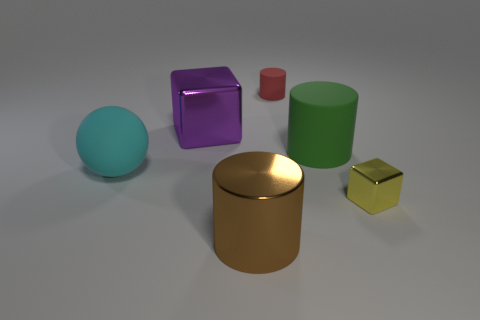Do the small thing in front of the large green cylinder and the big cyan thing have the same material?
Your answer should be very brief. No. What is the material of the big brown cylinder?
Your answer should be compact. Metal. There is a yellow cube that is the same size as the red cylinder; what is its material?
Make the answer very short. Metal. How many other large balls have the same color as the rubber sphere?
Provide a short and direct response. 0. There is a large cylinder that is in front of the shiny object that is on the right side of the matte cylinder in front of the red thing; what is it made of?
Ensure brevity in your answer.  Metal. What color is the thing that is behind the metal cube behind the large cyan ball?
Offer a terse response. Red. What number of small things are either purple objects or red metal balls?
Keep it short and to the point. 0. How many big green objects have the same material as the ball?
Ensure brevity in your answer.  1. How big is the shiny cube that is to the left of the brown cylinder?
Your response must be concise. Large. What shape is the tiny thing that is in front of the shiny block behind the large cyan rubber thing?
Your answer should be very brief. Cube. 